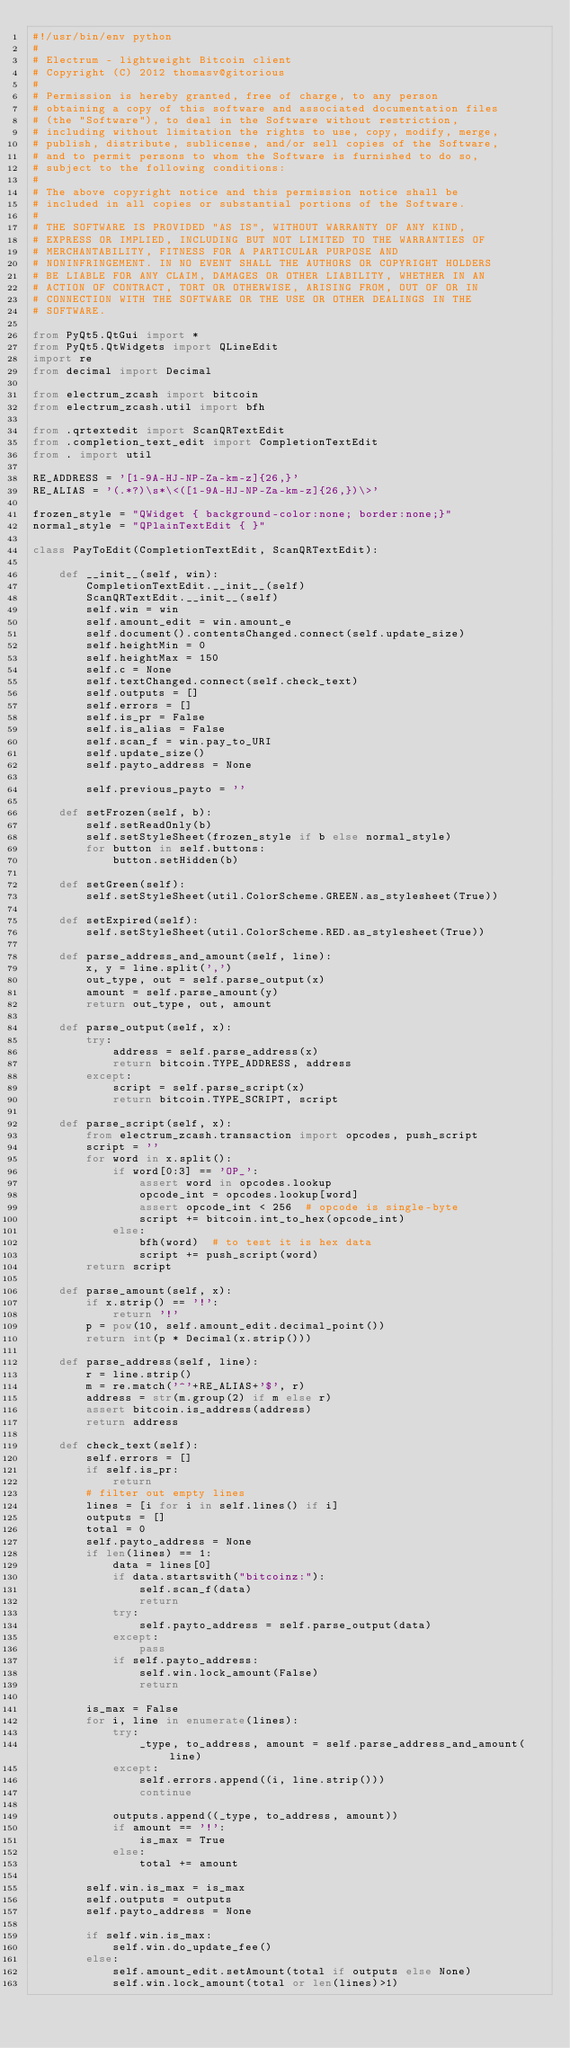Convert code to text. <code><loc_0><loc_0><loc_500><loc_500><_Python_>#!/usr/bin/env python
#
# Electrum - lightweight Bitcoin client
# Copyright (C) 2012 thomasv@gitorious
#
# Permission is hereby granted, free of charge, to any person
# obtaining a copy of this software and associated documentation files
# (the "Software"), to deal in the Software without restriction,
# including without limitation the rights to use, copy, modify, merge,
# publish, distribute, sublicense, and/or sell copies of the Software,
# and to permit persons to whom the Software is furnished to do so,
# subject to the following conditions:
#
# The above copyright notice and this permission notice shall be
# included in all copies or substantial portions of the Software.
#
# THE SOFTWARE IS PROVIDED "AS IS", WITHOUT WARRANTY OF ANY KIND,
# EXPRESS OR IMPLIED, INCLUDING BUT NOT LIMITED TO THE WARRANTIES OF
# MERCHANTABILITY, FITNESS FOR A PARTICULAR PURPOSE AND
# NONINFRINGEMENT. IN NO EVENT SHALL THE AUTHORS OR COPYRIGHT HOLDERS
# BE LIABLE FOR ANY CLAIM, DAMAGES OR OTHER LIABILITY, WHETHER IN AN
# ACTION OF CONTRACT, TORT OR OTHERWISE, ARISING FROM, OUT OF OR IN
# CONNECTION WITH THE SOFTWARE OR THE USE OR OTHER DEALINGS IN THE
# SOFTWARE.

from PyQt5.QtGui import *
from PyQt5.QtWidgets import QLineEdit
import re
from decimal import Decimal

from electrum_zcash import bitcoin
from electrum_zcash.util import bfh

from .qrtextedit import ScanQRTextEdit
from .completion_text_edit import CompletionTextEdit
from . import util

RE_ADDRESS = '[1-9A-HJ-NP-Za-km-z]{26,}'
RE_ALIAS = '(.*?)\s*\<([1-9A-HJ-NP-Za-km-z]{26,})\>'

frozen_style = "QWidget { background-color:none; border:none;}"
normal_style = "QPlainTextEdit { }"

class PayToEdit(CompletionTextEdit, ScanQRTextEdit):

    def __init__(self, win):
        CompletionTextEdit.__init__(self)
        ScanQRTextEdit.__init__(self)
        self.win = win
        self.amount_edit = win.amount_e
        self.document().contentsChanged.connect(self.update_size)
        self.heightMin = 0
        self.heightMax = 150
        self.c = None
        self.textChanged.connect(self.check_text)
        self.outputs = []
        self.errors = []
        self.is_pr = False
        self.is_alias = False
        self.scan_f = win.pay_to_URI
        self.update_size()
        self.payto_address = None

        self.previous_payto = ''

    def setFrozen(self, b):
        self.setReadOnly(b)
        self.setStyleSheet(frozen_style if b else normal_style)
        for button in self.buttons:
            button.setHidden(b)

    def setGreen(self):
        self.setStyleSheet(util.ColorScheme.GREEN.as_stylesheet(True))

    def setExpired(self):
        self.setStyleSheet(util.ColorScheme.RED.as_stylesheet(True))

    def parse_address_and_amount(self, line):
        x, y = line.split(',')
        out_type, out = self.parse_output(x)
        amount = self.parse_amount(y)
        return out_type, out, amount

    def parse_output(self, x):
        try:
            address = self.parse_address(x)
            return bitcoin.TYPE_ADDRESS, address
        except:
            script = self.parse_script(x)
            return bitcoin.TYPE_SCRIPT, script

    def parse_script(self, x):
        from electrum_zcash.transaction import opcodes, push_script
        script = ''
        for word in x.split():
            if word[0:3] == 'OP_':
                assert word in opcodes.lookup
                opcode_int = opcodes.lookup[word]
                assert opcode_int < 256  # opcode is single-byte
                script += bitcoin.int_to_hex(opcode_int)
            else:
                bfh(word)  # to test it is hex data
                script += push_script(word)
        return script

    def parse_amount(self, x):
        if x.strip() == '!':
            return '!'
        p = pow(10, self.amount_edit.decimal_point())
        return int(p * Decimal(x.strip()))

    def parse_address(self, line):
        r = line.strip()
        m = re.match('^'+RE_ALIAS+'$', r)
        address = str(m.group(2) if m else r)
        assert bitcoin.is_address(address)
        return address

    def check_text(self):
        self.errors = []
        if self.is_pr:
            return
        # filter out empty lines
        lines = [i for i in self.lines() if i]
        outputs = []
        total = 0
        self.payto_address = None
        if len(lines) == 1:
            data = lines[0]
            if data.startswith("bitcoinz:"):
                self.scan_f(data)
                return
            try:
                self.payto_address = self.parse_output(data)
            except:
                pass
            if self.payto_address:
                self.win.lock_amount(False)
                return

        is_max = False
        for i, line in enumerate(lines):
            try:
                _type, to_address, amount = self.parse_address_and_amount(line)
            except:
                self.errors.append((i, line.strip()))
                continue

            outputs.append((_type, to_address, amount))
            if amount == '!':
                is_max = True
            else:
                total += amount

        self.win.is_max = is_max
        self.outputs = outputs
        self.payto_address = None

        if self.win.is_max:
            self.win.do_update_fee()
        else:
            self.amount_edit.setAmount(total if outputs else None)
            self.win.lock_amount(total or len(lines)>1)
</code> 